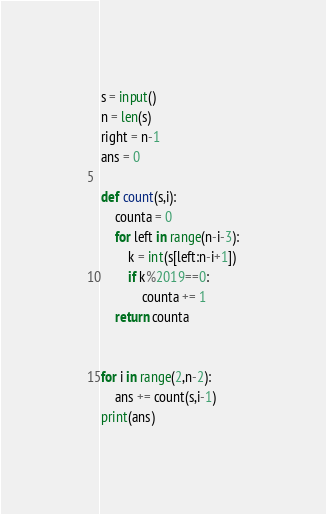Convert code to text. <code><loc_0><loc_0><loc_500><loc_500><_Python_>s = input()
n = len(s)
right = n-1
ans = 0

def count(s,i):
    counta = 0
    for left in range(n-i-3):
        k = int(s[left:n-i+1])
        if k%2019==0:
            counta += 1
    return counta


for i in range(2,n-2):
    ans += count(s,i-1)
print(ans)
</code> 